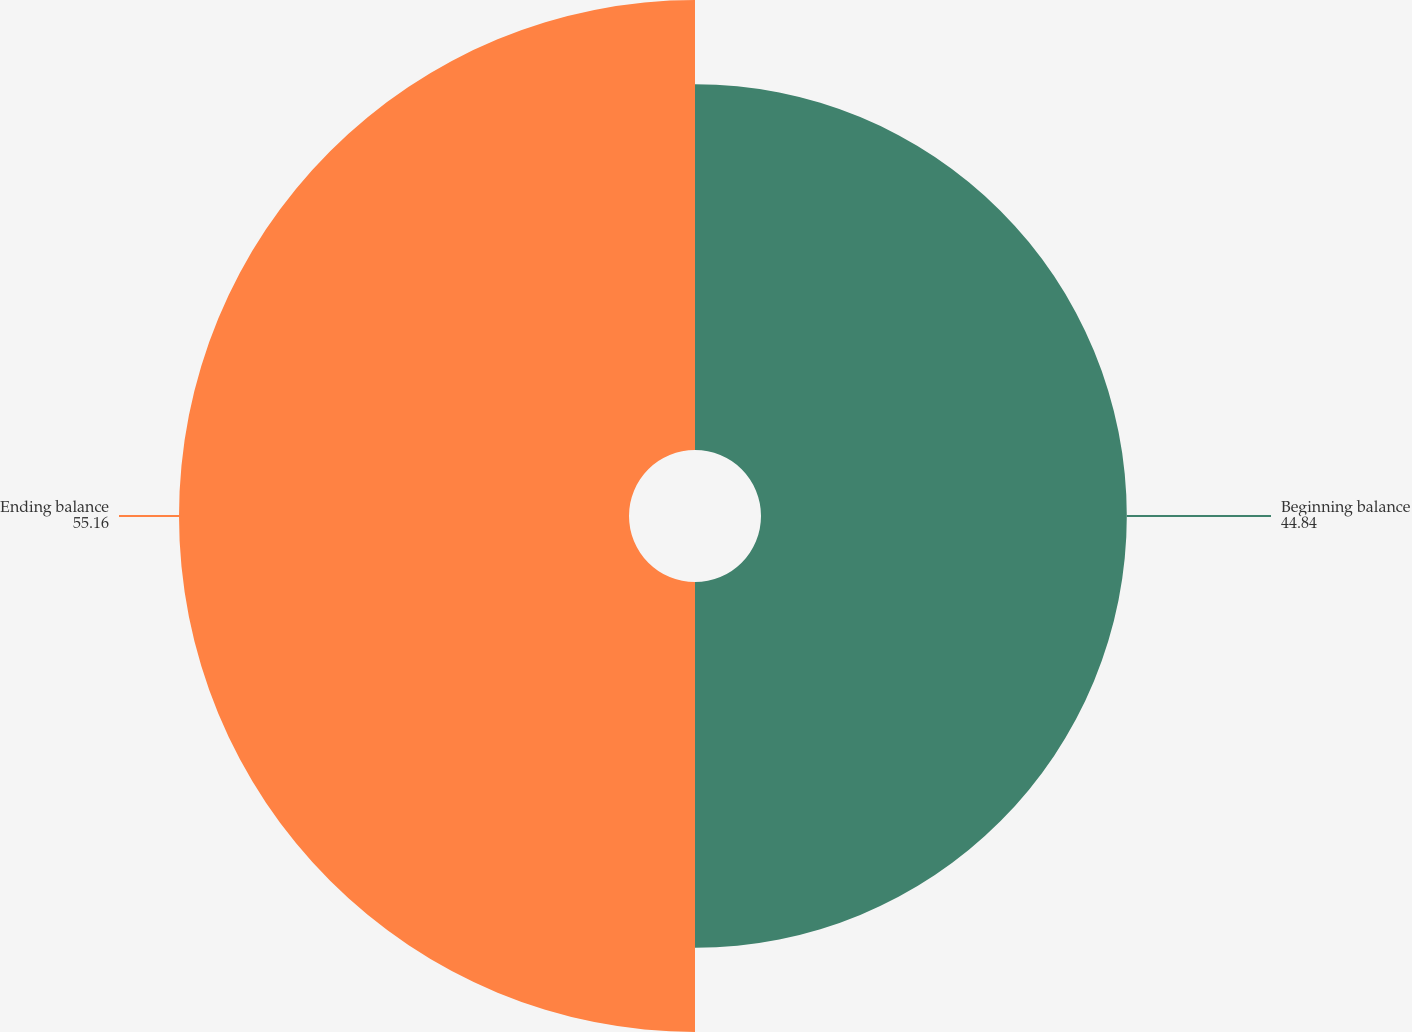Convert chart. <chart><loc_0><loc_0><loc_500><loc_500><pie_chart><fcel>Beginning balance<fcel>Ending balance<nl><fcel>44.84%<fcel>55.16%<nl></chart> 